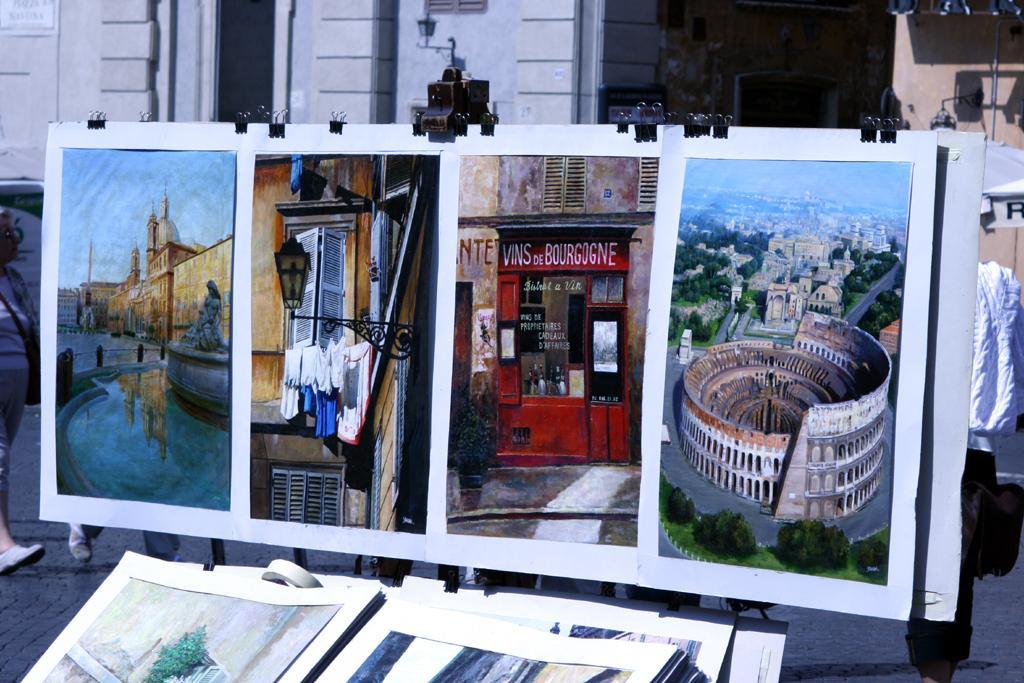In one or two sentences, can you explain what this image depicts? In this image we can see a poster with some different images and clips attached to it, there are some people and in the background, we can see a few buildings, at the bottom of the image we can see a poster which is truncated. 